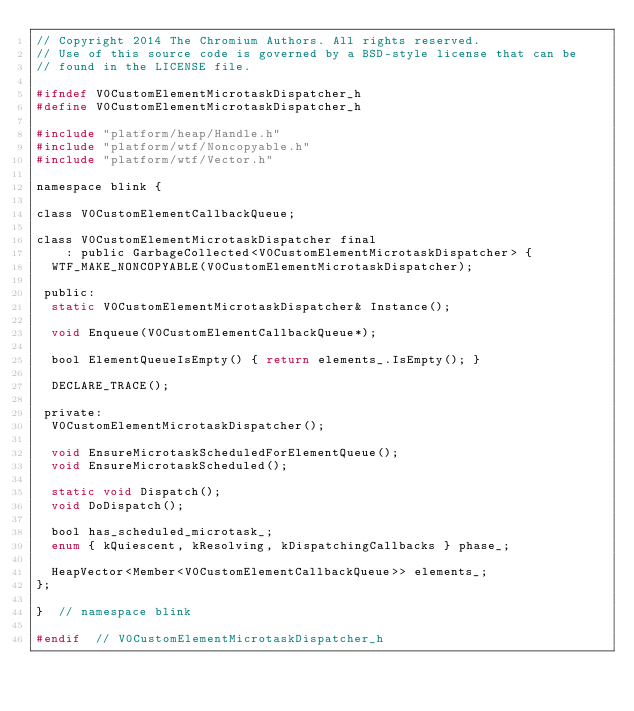Convert code to text. <code><loc_0><loc_0><loc_500><loc_500><_C_>// Copyright 2014 The Chromium Authors. All rights reserved.
// Use of this source code is governed by a BSD-style license that can be
// found in the LICENSE file.

#ifndef V0CustomElementMicrotaskDispatcher_h
#define V0CustomElementMicrotaskDispatcher_h

#include "platform/heap/Handle.h"
#include "platform/wtf/Noncopyable.h"
#include "platform/wtf/Vector.h"

namespace blink {

class V0CustomElementCallbackQueue;

class V0CustomElementMicrotaskDispatcher final
    : public GarbageCollected<V0CustomElementMicrotaskDispatcher> {
  WTF_MAKE_NONCOPYABLE(V0CustomElementMicrotaskDispatcher);

 public:
  static V0CustomElementMicrotaskDispatcher& Instance();

  void Enqueue(V0CustomElementCallbackQueue*);

  bool ElementQueueIsEmpty() { return elements_.IsEmpty(); }

  DECLARE_TRACE();

 private:
  V0CustomElementMicrotaskDispatcher();

  void EnsureMicrotaskScheduledForElementQueue();
  void EnsureMicrotaskScheduled();

  static void Dispatch();
  void DoDispatch();

  bool has_scheduled_microtask_;
  enum { kQuiescent, kResolving, kDispatchingCallbacks } phase_;

  HeapVector<Member<V0CustomElementCallbackQueue>> elements_;
};

}  // namespace blink

#endif  // V0CustomElementMicrotaskDispatcher_h
</code> 